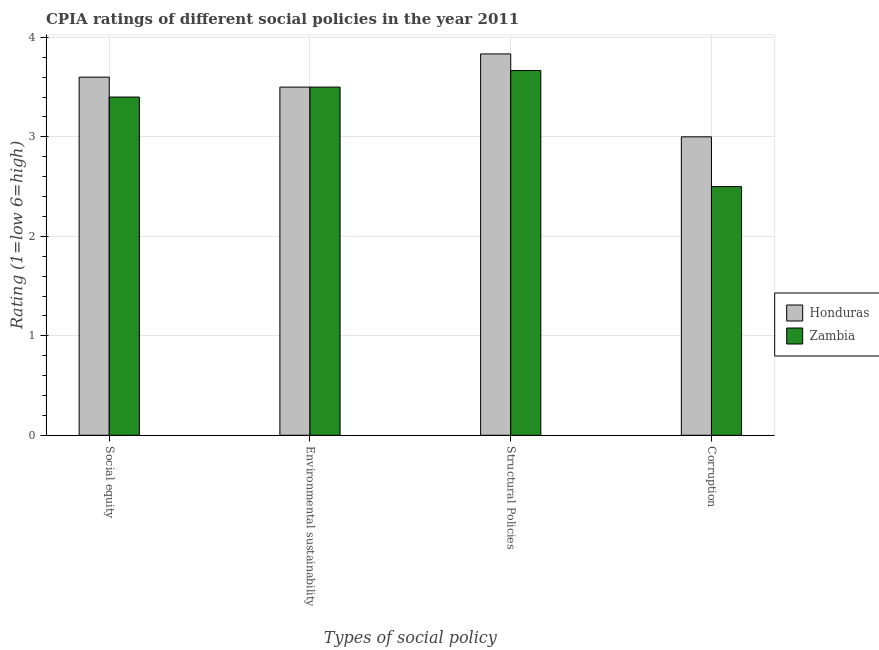How many groups of bars are there?
Offer a terse response. 4. Are the number of bars per tick equal to the number of legend labels?
Keep it short and to the point. Yes. Are the number of bars on each tick of the X-axis equal?
Your answer should be very brief. Yes. How many bars are there on the 3rd tick from the right?
Provide a succinct answer. 2. What is the label of the 1st group of bars from the left?
Provide a succinct answer. Social equity. Across all countries, what is the maximum cpia rating of structural policies?
Your response must be concise. 3.83. Across all countries, what is the minimum cpia rating of environmental sustainability?
Make the answer very short. 3.5. In which country was the cpia rating of corruption maximum?
Provide a short and direct response. Honduras. In which country was the cpia rating of corruption minimum?
Give a very brief answer. Zambia. What is the total cpia rating of environmental sustainability in the graph?
Provide a succinct answer. 7. What is the difference between the cpia rating of social equity in Zambia and that in Honduras?
Provide a short and direct response. -0.2. What is the difference between the cpia rating of social equity in Zambia and the cpia rating of environmental sustainability in Honduras?
Make the answer very short. -0.1. What is the average cpia rating of structural policies per country?
Keep it short and to the point. 3.75. What is the difference between the cpia rating of social equity and cpia rating of corruption in Zambia?
Offer a terse response. 0.9. What is the ratio of the cpia rating of social equity in Honduras to that in Zambia?
Your answer should be very brief. 1.06. Is the difference between the cpia rating of environmental sustainability in Zambia and Honduras greater than the difference between the cpia rating of structural policies in Zambia and Honduras?
Your answer should be very brief. Yes. What is the difference between the highest and the second highest cpia rating of corruption?
Offer a terse response. 0.5. What is the difference between the highest and the lowest cpia rating of social equity?
Give a very brief answer. 0.2. In how many countries, is the cpia rating of corruption greater than the average cpia rating of corruption taken over all countries?
Make the answer very short. 1. Is it the case that in every country, the sum of the cpia rating of corruption and cpia rating of environmental sustainability is greater than the sum of cpia rating of social equity and cpia rating of structural policies?
Provide a short and direct response. No. What does the 2nd bar from the left in Structural Policies represents?
Your response must be concise. Zambia. What does the 1st bar from the right in Corruption represents?
Provide a succinct answer. Zambia. Is it the case that in every country, the sum of the cpia rating of social equity and cpia rating of environmental sustainability is greater than the cpia rating of structural policies?
Offer a very short reply. Yes. How many bars are there?
Provide a succinct answer. 8. Are all the bars in the graph horizontal?
Offer a terse response. No. How many countries are there in the graph?
Your answer should be compact. 2. Are the values on the major ticks of Y-axis written in scientific E-notation?
Provide a succinct answer. No. Does the graph contain any zero values?
Your answer should be very brief. No. How are the legend labels stacked?
Make the answer very short. Vertical. What is the title of the graph?
Offer a terse response. CPIA ratings of different social policies in the year 2011. What is the label or title of the X-axis?
Keep it short and to the point. Types of social policy. What is the Rating (1=low 6=high) in Honduras in Environmental sustainability?
Your answer should be compact. 3.5. What is the Rating (1=low 6=high) in Honduras in Structural Policies?
Offer a very short reply. 3.83. What is the Rating (1=low 6=high) of Zambia in Structural Policies?
Your answer should be very brief. 3.67. What is the Rating (1=low 6=high) in Honduras in Corruption?
Keep it short and to the point. 3. Across all Types of social policy, what is the maximum Rating (1=low 6=high) of Honduras?
Ensure brevity in your answer.  3.83. Across all Types of social policy, what is the maximum Rating (1=low 6=high) in Zambia?
Keep it short and to the point. 3.67. Across all Types of social policy, what is the minimum Rating (1=low 6=high) of Honduras?
Your answer should be very brief. 3. What is the total Rating (1=low 6=high) of Honduras in the graph?
Provide a short and direct response. 13.93. What is the total Rating (1=low 6=high) in Zambia in the graph?
Your answer should be very brief. 13.07. What is the difference between the Rating (1=low 6=high) of Honduras in Social equity and that in Environmental sustainability?
Provide a short and direct response. 0.1. What is the difference between the Rating (1=low 6=high) of Honduras in Social equity and that in Structural Policies?
Keep it short and to the point. -0.23. What is the difference between the Rating (1=low 6=high) in Zambia in Social equity and that in Structural Policies?
Provide a succinct answer. -0.27. What is the difference between the Rating (1=low 6=high) in Honduras in Social equity and that in Corruption?
Offer a terse response. 0.6. What is the difference between the Rating (1=low 6=high) in Zambia in Social equity and that in Corruption?
Ensure brevity in your answer.  0.9. What is the difference between the Rating (1=low 6=high) in Honduras in Environmental sustainability and that in Structural Policies?
Your answer should be very brief. -0.33. What is the difference between the Rating (1=low 6=high) in Honduras in Environmental sustainability and that in Corruption?
Offer a very short reply. 0.5. What is the difference between the Rating (1=low 6=high) in Zambia in Environmental sustainability and that in Corruption?
Offer a terse response. 1. What is the difference between the Rating (1=low 6=high) of Honduras in Structural Policies and that in Corruption?
Make the answer very short. 0.83. What is the difference between the Rating (1=low 6=high) of Honduras in Social equity and the Rating (1=low 6=high) of Zambia in Environmental sustainability?
Keep it short and to the point. 0.1. What is the difference between the Rating (1=low 6=high) in Honduras in Social equity and the Rating (1=low 6=high) in Zambia in Structural Policies?
Give a very brief answer. -0.07. What is the difference between the Rating (1=low 6=high) in Honduras in Social equity and the Rating (1=low 6=high) in Zambia in Corruption?
Your answer should be compact. 1.1. What is the difference between the Rating (1=low 6=high) in Honduras in Environmental sustainability and the Rating (1=low 6=high) in Zambia in Corruption?
Offer a very short reply. 1. What is the average Rating (1=low 6=high) of Honduras per Types of social policy?
Keep it short and to the point. 3.48. What is the average Rating (1=low 6=high) in Zambia per Types of social policy?
Keep it short and to the point. 3.27. What is the difference between the Rating (1=low 6=high) in Honduras and Rating (1=low 6=high) in Zambia in Corruption?
Keep it short and to the point. 0.5. What is the ratio of the Rating (1=low 6=high) in Honduras in Social equity to that in Environmental sustainability?
Make the answer very short. 1.03. What is the ratio of the Rating (1=low 6=high) in Zambia in Social equity to that in Environmental sustainability?
Offer a very short reply. 0.97. What is the ratio of the Rating (1=low 6=high) in Honduras in Social equity to that in Structural Policies?
Make the answer very short. 0.94. What is the ratio of the Rating (1=low 6=high) of Zambia in Social equity to that in Structural Policies?
Provide a succinct answer. 0.93. What is the ratio of the Rating (1=low 6=high) in Honduras in Social equity to that in Corruption?
Your answer should be compact. 1.2. What is the ratio of the Rating (1=low 6=high) in Zambia in Social equity to that in Corruption?
Offer a terse response. 1.36. What is the ratio of the Rating (1=low 6=high) in Honduras in Environmental sustainability to that in Structural Policies?
Ensure brevity in your answer.  0.91. What is the ratio of the Rating (1=low 6=high) of Zambia in Environmental sustainability to that in Structural Policies?
Your answer should be very brief. 0.95. What is the ratio of the Rating (1=low 6=high) in Honduras in Environmental sustainability to that in Corruption?
Make the answer very short. 1.17. What is the ratio of the Rating (1=low 6=high) in Honduras in Structural Policies to that in Corruption?
Ensure brevity in your answer.  1.28. What is the ratio of the Rating (1=low 6=high) of Zambia in Structural Policies to that in Corruption?
Offer a very short reply. 1.47. What is the difference between the highest and the second highest Rating (1=low 6=high) in Honduras?
Your answer should be very brief. 0.23. What is the difference between the highest and the second highest Rating (1=low 6=high) of Zambia?
Offer a very short reply. 0.17. What is the difference between the highest and the lowest Rating (1=low 6=high) in Zambia?
Provide a succinct answer. 1.17. 